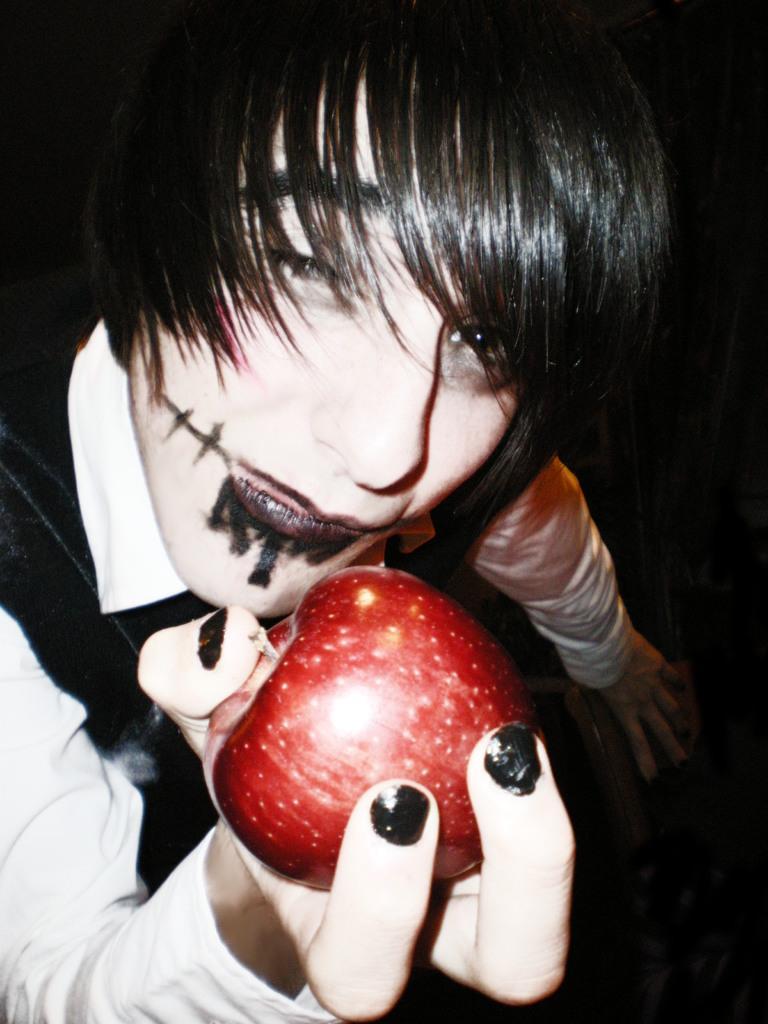In one or two sentences, can you explain what this image depicts? In this image, we can see a person holding an apple and an object. We can also see the dark background. 